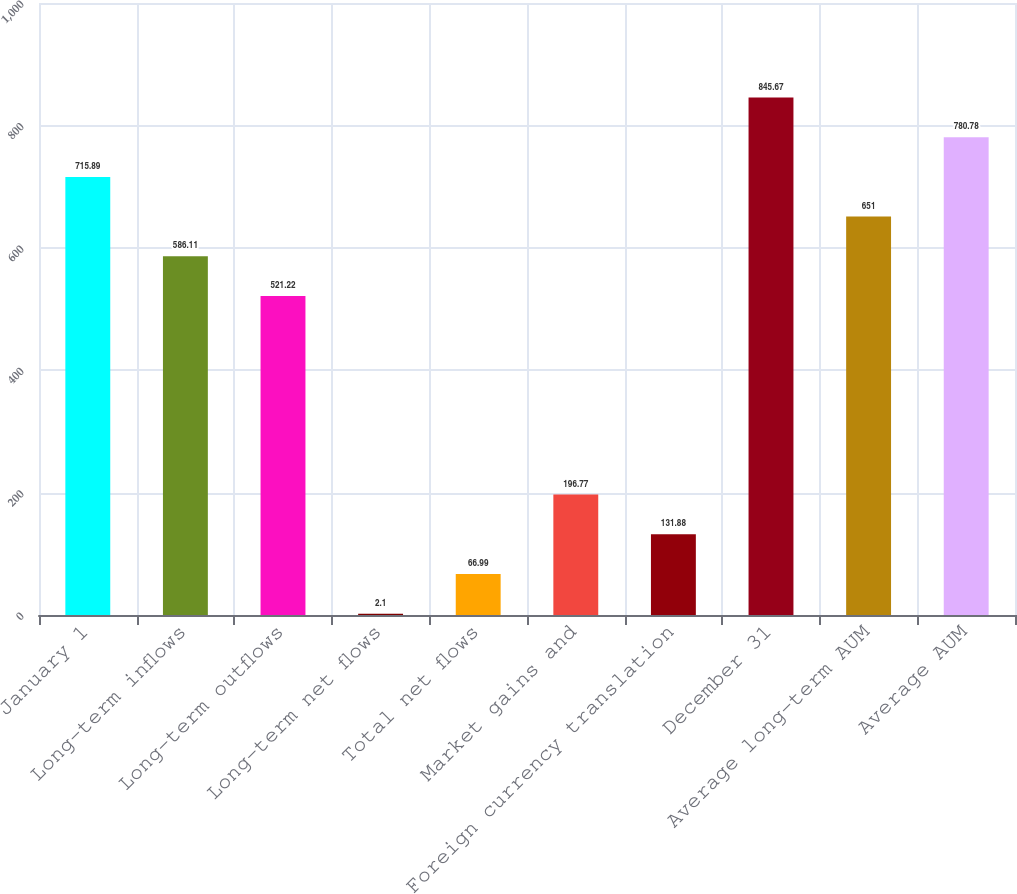<chart> <loc_0><loc_0><loc_500><loc_500><bar_chart><fcel>January 1<fcel>Long-term inflows<fcel>Long-term outflows<fcel>Long-term net flows<fcel>Total net flows<fcel>Market gains and<fcel>Foreign currency translation<fcel>December 31<fcel>Average long-term AUM<fcel>Average AUM<nl><fcel>715.89<fcel>586.11<fcel>521.22<fcel>2.1<fcel>66.99<fcel>196.77<fcel>131.88<fcel>845.67<fcel>651<fcel>780.78<nl></chart> 